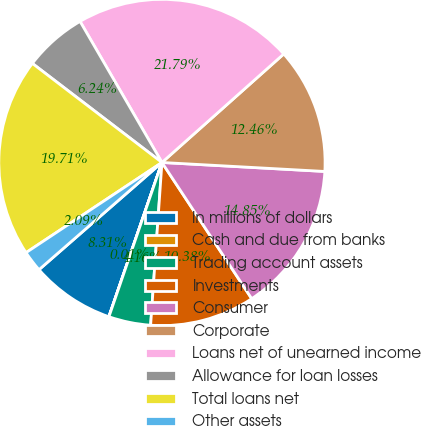Convert chart to OTSL. <chart><loc_0><loc_0><loc_500><loc_500><pie_chart><fcel>In millions of dollars<fcel>Cash and due from banks<fcel>Trading account assets<fcel>Investments<fcel>Consumer<fcel>Corporate<fcel>Loans net of unearned income<fcel>Allowance for loan losses<fcel>Total loans net<fcel>Other assets<nl><fcel>8.31%<fcel>0.01%<fcel>4.16%<fcel>10.38%<fcel>14.85%<fcel>12.46%<fcel>21.79%<fcel>6.24%<fcel>19.71%<fcel>2.09%<nl></chart> 